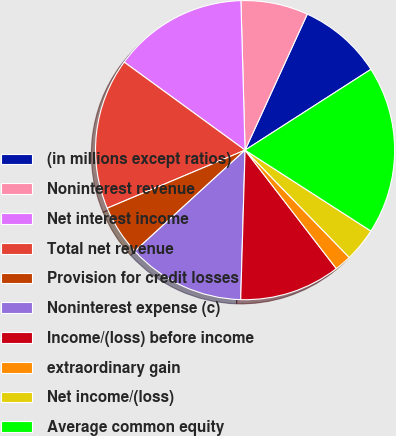<chart> <loc_0><loc_0><loc_500><loc_500><pie_chart><fcel>(in millions except ratios)<fcel>Noninterest revenue<fcel>Net interest income<fcel>Total net revenue<fcel>Provision for credit losses<fcel>Noninterest expense (c)<fcel>Income/(loss) before income<fcel>extraordinary gain<fcel>Net income/(loss)<fcel>Average common equity<nl><fcel>9.09%<fcel>7.27%<fcel>14.54%<fcel>16.36%<fcel>5.46%<fcel>12.73%<fcel>10.91%<fcel>1.82%<fcel>3.64%<fcel>18.18%<nl></chart> 